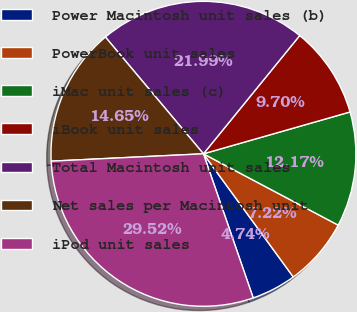Convert chart to OTSL. <chart><loc_0><loc_0><loc_500><loc_500><pie_chart><fcel>Power Macintosh unit sales (b)<fcel>PowerBook unit sales<fcel>iMac unit sales (c)<fcel>iBook unit sales<fcel>Total Macintosh unit sales<fcel>Net sales per Macintosh unit<fcel>iPod unit sales<nl><fcel>4.74%<fcel>7.22%<fcel>12.17%<fcel>9.7%<fcel>21.99%<fcel>14.65%<fcel>29.52%<nl></chart> 